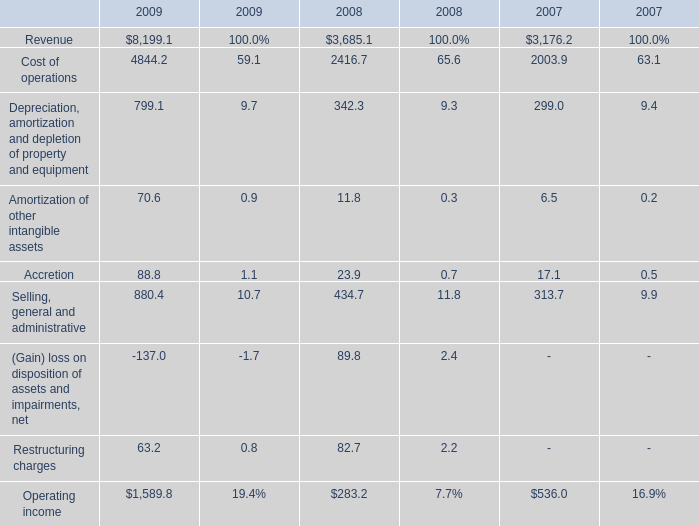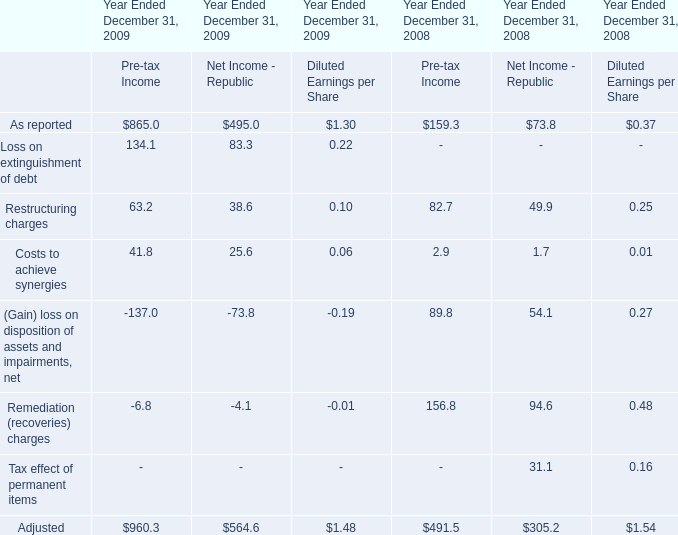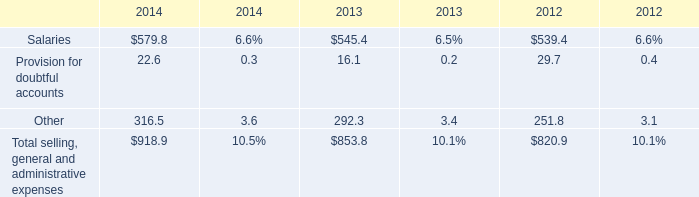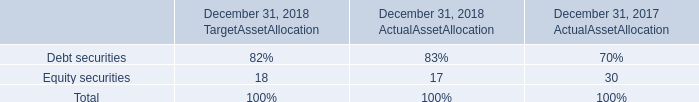what was the percentage decline in the equity from 2017 to 2018 actual 
Computations: ((17 - 30) / 30)
Answer: -0.43333. 